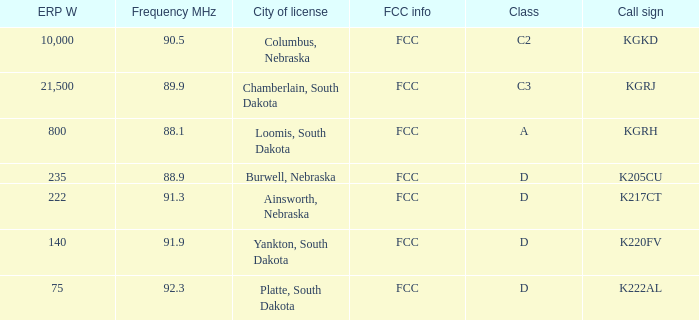What is the average frequency mhz of the loomis, south dakota city license? 88.1. 